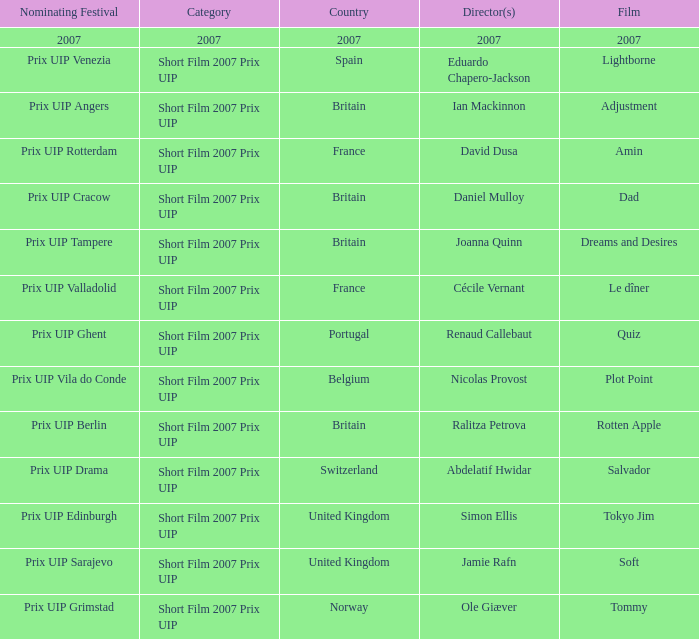What film did ian mackinnon direct that was in the short film 2007 prix uip category? Adjustment. 